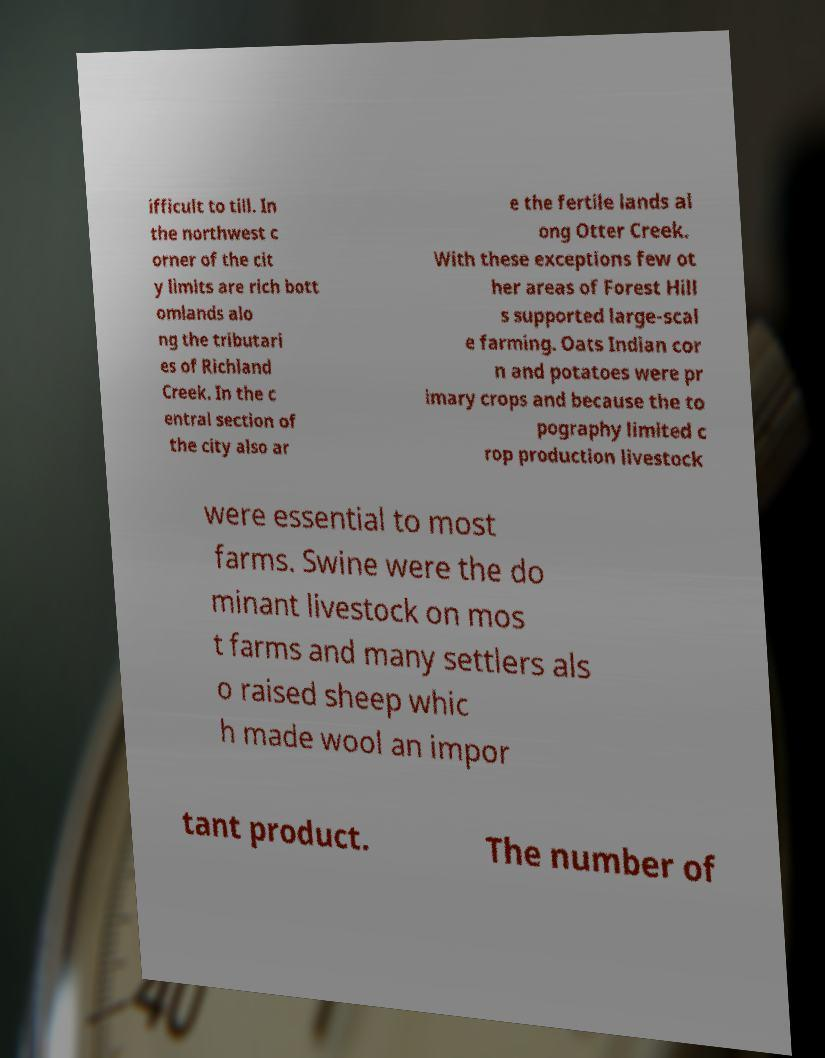What messages or text are displayed in this image? I need them in a readable, typed format. ifficult to till. In the northwest c orner of the cit y limits are rich bott omlands alo ng the tributari es of Richland Creek. In the c entral section of the city also ar e the fertile lands al ong Otter Creek. With these exceptions few ot her areas of Forest Hill s supported large-scal e farming. Oats Indian cor n and potatoes were pr imary crops and because the to pography limited c rop production livestock were essential to most farms. Swine were the do minant livestock on mos t farms and many settlers als o raised sheep whic h made wool an impor tant product. The number of 